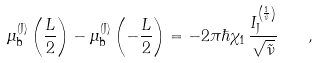Convert formula to latex. <formula><loc_0><loc_0><loc_500><loc_500>\mu _ { \text {b} } ^ { \text {(J)} } \left ( \frac { L } { 2 } \right ) - \mu _ { \text {b} } ^ { \text {(J)} } \left ( - \frac { L } { 2 } \right ) = - 2 \pi \hbar { \chi } _ { 1 } \, \frac { I _ { \text {J} } ^ { \left ( \frac { 1 } { \tilde { \nu } } \right ) } } { \sqrt { \tilde { \nu } } } \quad ,</formula> 